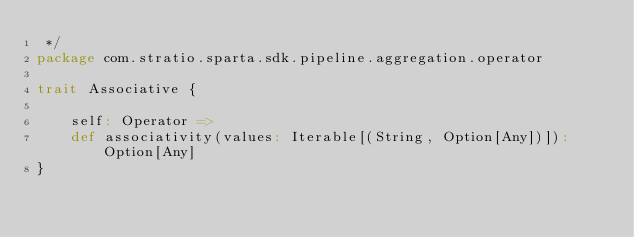Convert code to text. <code><loc_0><loc_0><loc_500><loc_500><_Scala_> */
package com.stratio.sparta.sdk.pipeline.aggregation.operator

trait Associative {

    self: Operator =>
    def associativity(values: Iterable[(String, Option[Any])]): Option[Any]
}
</code> 